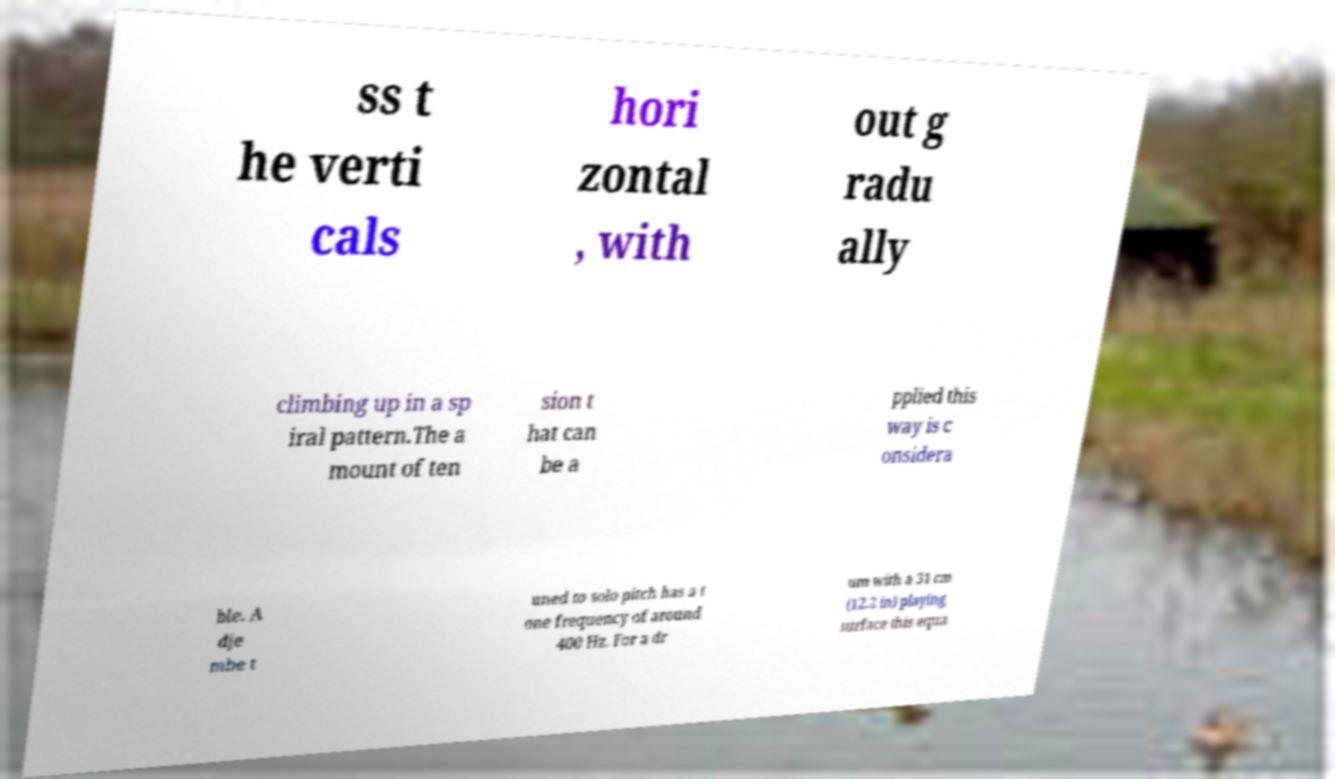Could you assist in decoding the text presented in this image and type it out clearly? ss t he verti cals hori zontal , with out g radu ally climbing up in a sp iral pattern.The a mount of ten sion t hat can be a pplied this way is c onsidera ble. A dje mbe t uned to solo pitch has a t one frequency of around 400 Hz. For a dr um with a 31 cm (12.2 in) playing surface this equa 